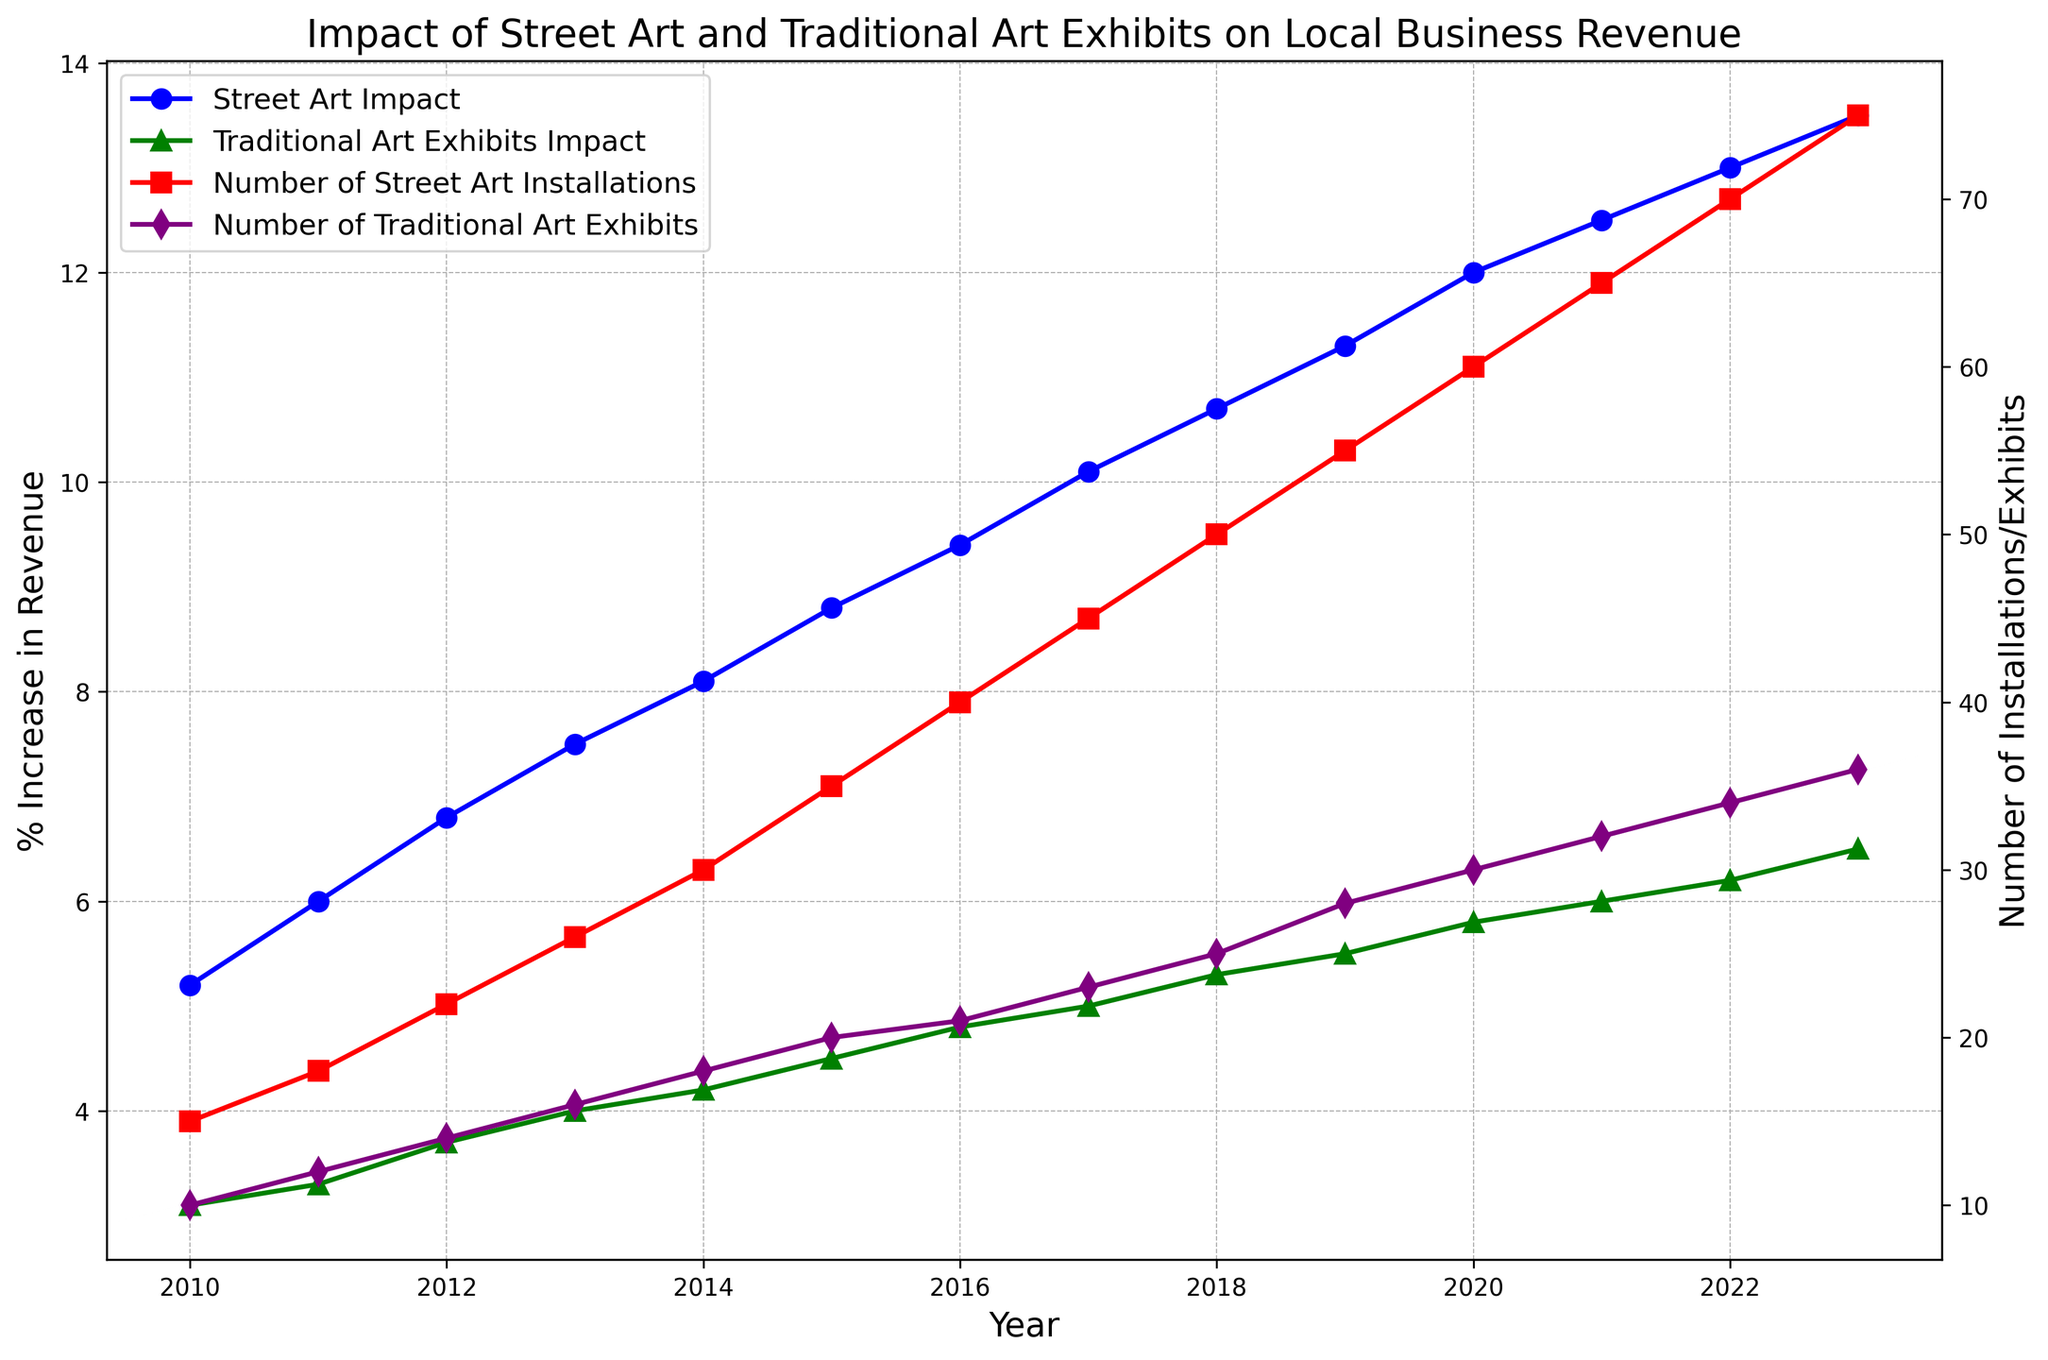What year saw the highest revenue increase due to street art? Look at the blue line which represents the street art impact, find the highest point on the line and trace it back to the year on the x-axis.
Answer: 2023 Which type of art exhibit has more installations/exhibits in 2015, street art or traditional art exhibits? Compare the red and purple markers for the year 2015; red represents street art installations and purple represents traditional art exhibits. Count the markers to see which is higher.
Answer: Street Art By how much did the impact of traditional art exhibits increase from 2010 to 2023? Check the green line for initial and final values. The initial value in 2010 is 3.1% and the final value in 2023 is 6.5%. The increase is calculated by subtracting the initial from the final value: 6.5% - 3.1%.
Answer: 3.4% What is the difference in the number of street art installations between 2010 and 2023? Look at the red markers for the years 2010 and 2023. In 2010, there are 15 installations and in 2023 there are 75. Subtract 15 from 75 to get the difference.
Answer: 60 Which year marks the first time the impact of street art on local business revenue surpasses 10%? Observe when the blue line crosses the 10% mark on the y-axis. Trace this point downward to check the corresponding year.
Answer: 2017 Compare the impact on local business revenue of street art and traditional art exhibits in 2022. Which has a higher impact and by how much? Observe the values of the blue and green lines in the year 2022. The blue line (street art) shows 13.0%, and the green line (traditional art) shows 6.2%. Subtract the two values to find the difference.
Answer: Street art by 6.8% What is the trend in the number of traditional art exhibits from 2010 to 2023? Follow the purple line showing the number of traditional art exhibits over the years. Describe whether the line goes up, down, or stays the same.
Answer: Increasing In which year do we see the same number of installations for street art and traditional art? Look for the point where the red and purple lines cross each other, indicating the same number of installations for both types of art.
Answer: 2015 What is the average annual increase in the number of street art installations from 2010 to 2023? Calculate the total increase from 2010 to 2023 (75 - 15 = 60). There are 13 intervals between these years (2023-2010). Divide the total increase by the number of intervals: 60 / 13.
Answer: Approximately 4.6 By what percentage did the impact of street art increase from 2016 to 2023? The initial value in 2016 is 9.4% and the final value in 2023 is 13.5%. The percentage increase is calculated by subtracting the initial value from the final value and then dividing by the initial value: (13.5 - 9.4) / 9.4 * 100.
Answer: Approximately 43.6% 